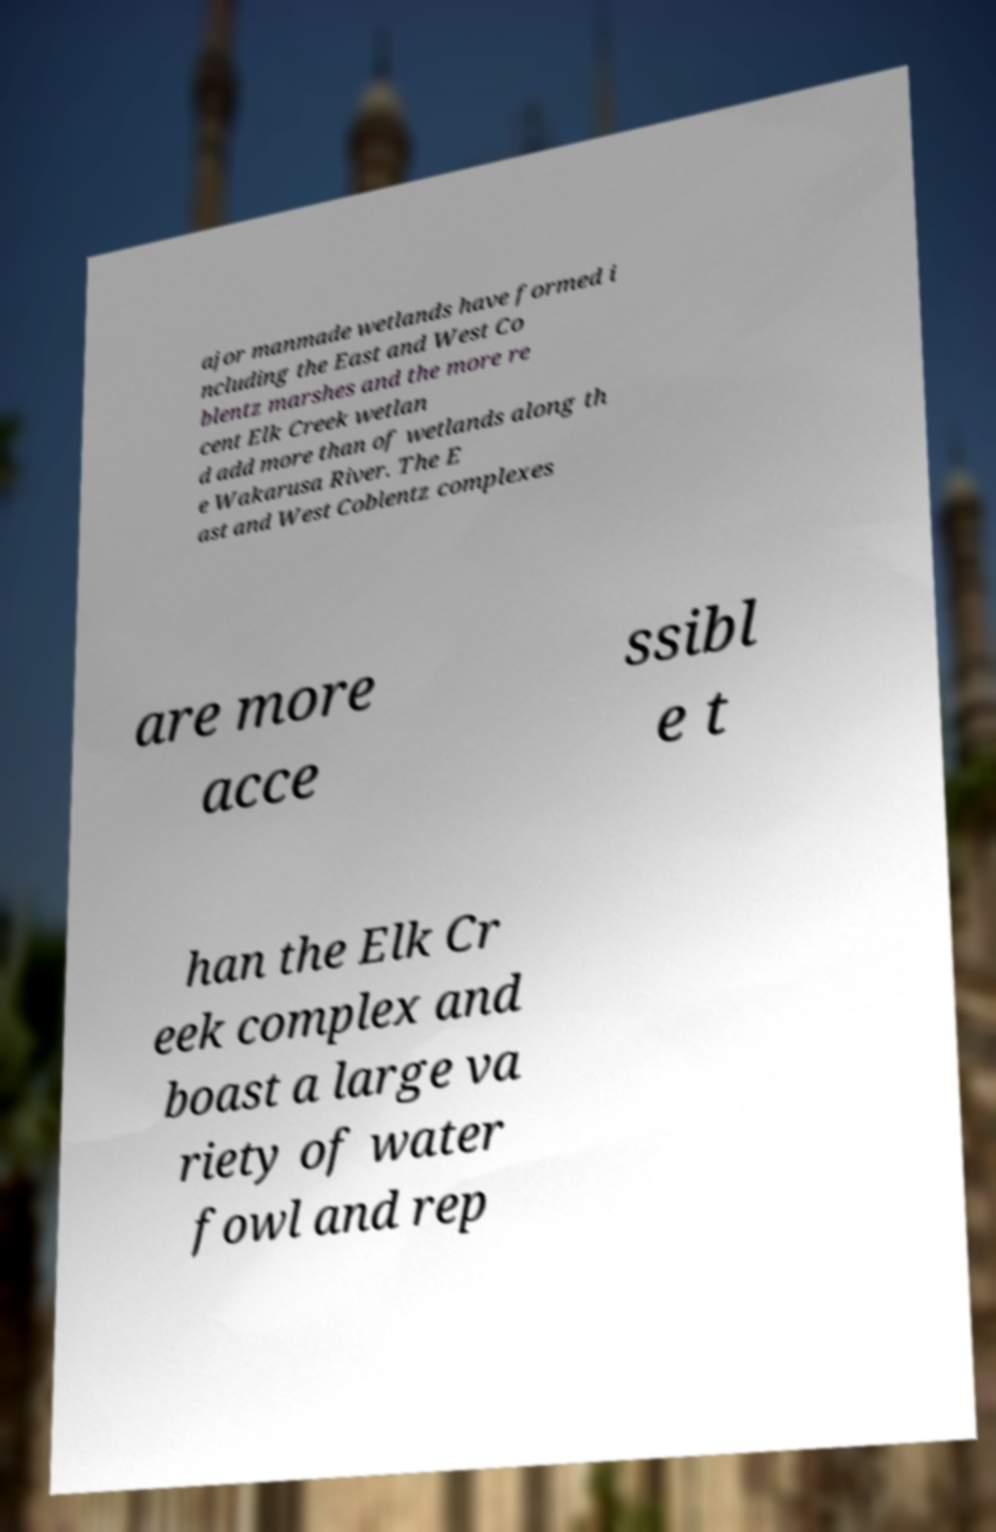Can you accurately transcribe the text from the provided image for me? ajor manmade wetlands have formed i ncluding the East and West Co blentz marshes and the more re cent Elk Creek wetlan d add more than of wetlands along th e Wakarusa River. The E ast and West Coblentz complexes are more acce ssibl e t han the Elk Cr eek complex and boast a large va riety of water fowl and rep 